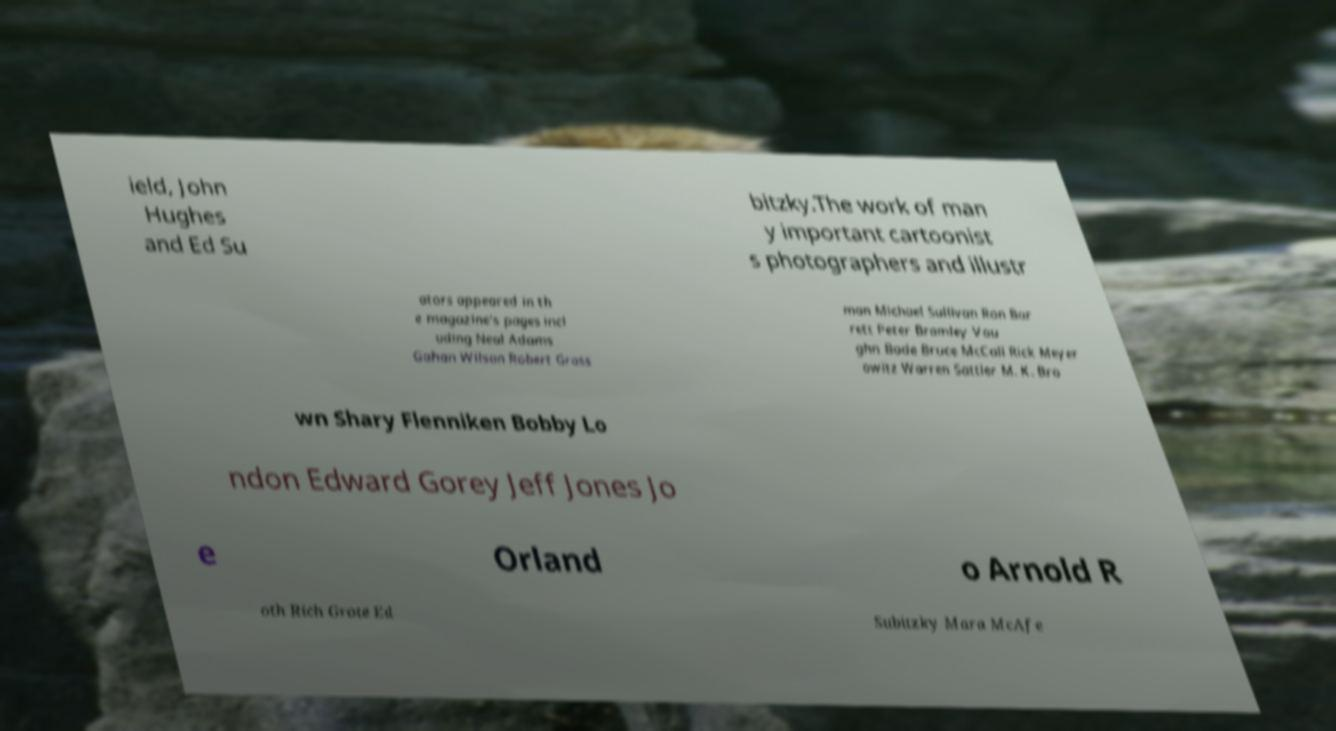For documentation purposes, I need the text within this image transcribed. Could you provide that? ield, John Hughes and Ed Su bitzky.The work of man y important cartoonist s photographers and illustr ators appeared in th e magazine's pages incl uding Neal Adams Gahan Wilson Robert Gross man Michael Sullivan Ron Bar rett Peter Bramley Vau ghn Bode Bruce McCall Rick Meyer owitz Warren Sattler M. K. Bro wn Shary Flenniken Bobby Lo ndon Edward Gorey Jeff Jones Jo e Orland o Arnold R oth Rich Grote Ed Subitzky Mara McAfe 